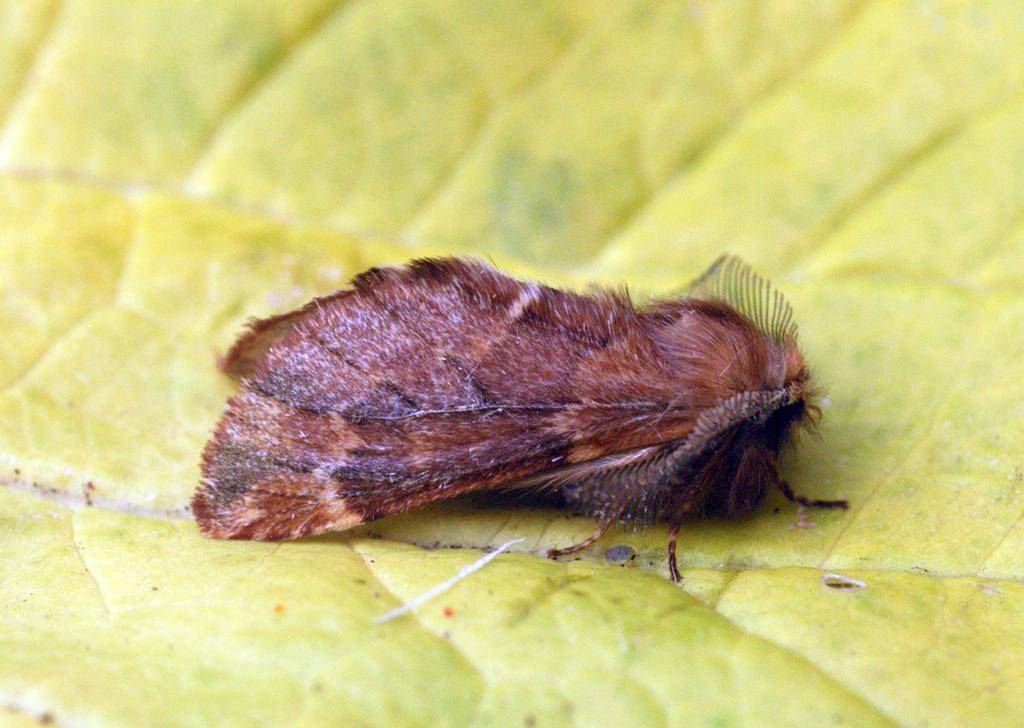What is the main subject in the center of the image? There is an insect in the center of the image. What can be seen at the bottom of the image? There is a leaf at the bottom of the image. What type of locket is the insect wearing in the image? There is no locket present in the image, and the insect is not wearing any jewelry. 